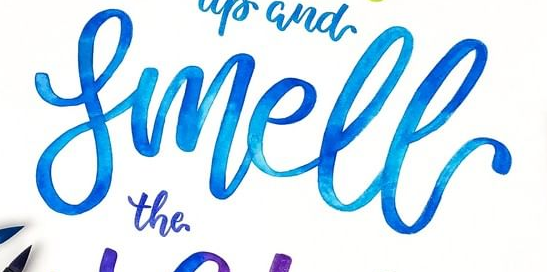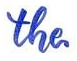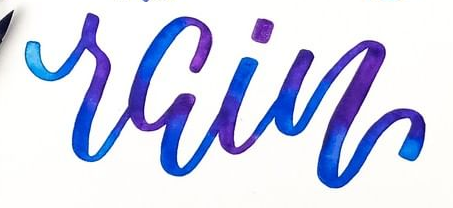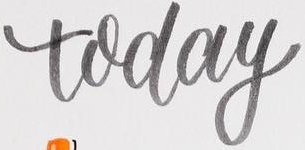Identify the words shown in these images in order, separated by a semicolon. Smell; the; rain; today 